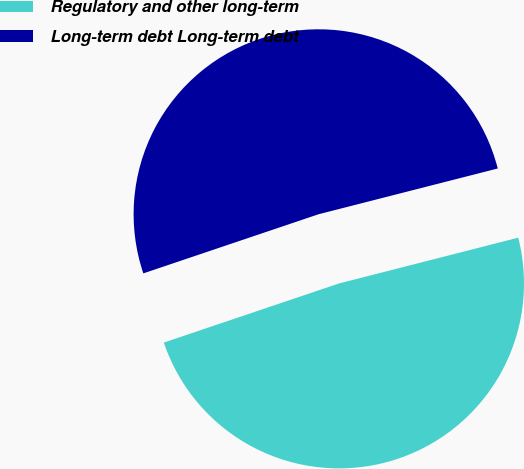<chart> <loc_0><loc_0><loc_500><loc_500><pie_chart><fcel>Regulatory and other long-term<fcel>Long-term debt Long-term debt<nl><fcel>48.8%<fcel>51.2%<nl></chart> 